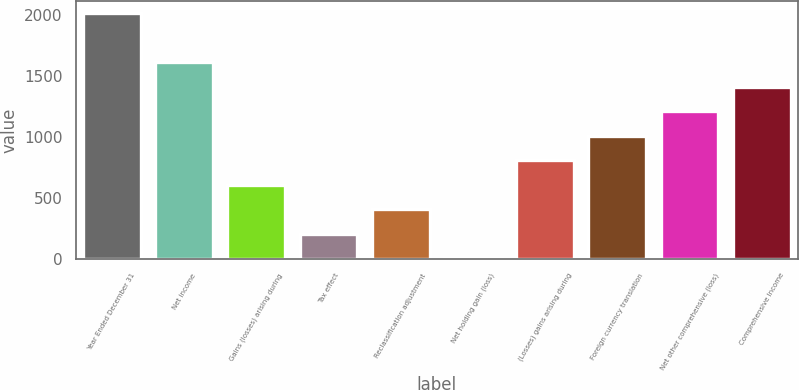Convert chart. <chart><loc_0><loc_0><loc_500><loc_500><bar_chart><fcel>Year Ended December 31<fcel>Net income<fcel>Gains (losses) arising during<fcel>Tax effect<fcel>Reclassification adjustment<fcel>Net holding gain (loss)<fcel>(Losses) gains arising during<fcel>Foreign currency translation<fcel>Net other comprehensive (loss)<fcel>Comprehensive Income<nl><fcel>2014<fcel>1612.3<fcel>608.05<fcel>206.35<fcel>407.2<fcel>5.5<fcel>808.9<fcel>1009.75<fcel>1210.6<fcel>1411.45<nl></chart> 